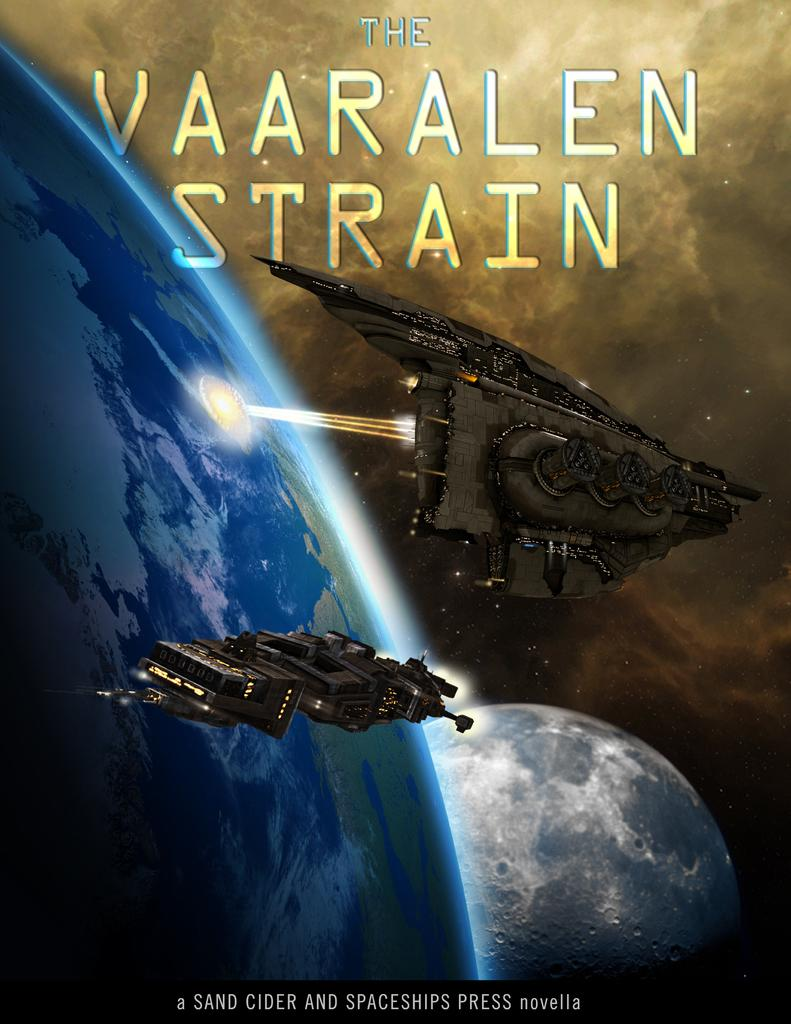What is featured in the image? There is a poster in the image, along with two spaceships and planets. Can you describe the poster in the image? The poster features two spaceships and planets. Is there any text or writing on the image? Yes, there is text or writing on the image. How many pigs are wearing masks in the image? There are no pigs or masks present in the image. What type of credit card is being used in the image? There is no credit card or any financial transaction depicted in the image. 